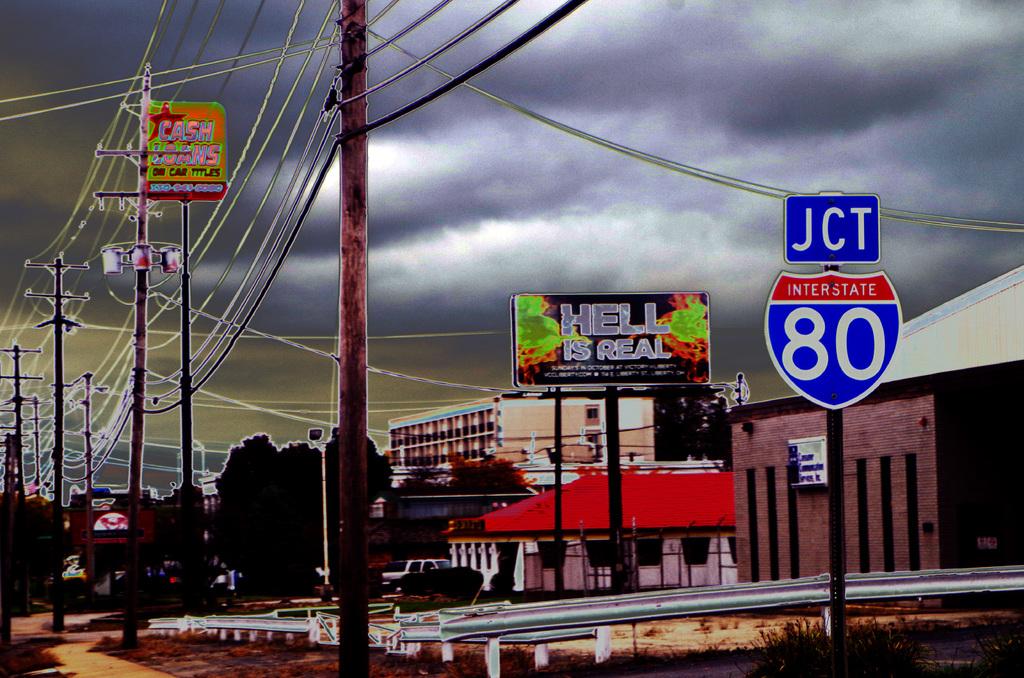What is the billboard stating is real?
Make the answer very short. Hell. What interstate is the sign for?
Give a very brief answer. 80. 